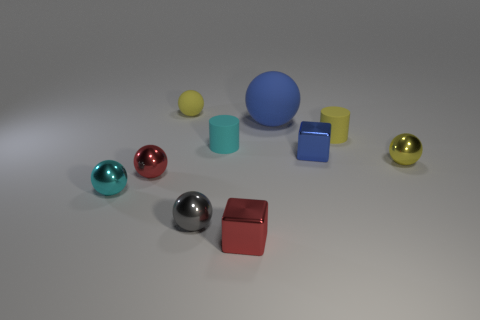Is there anything else that has the same material as the blue ball?
Provide a short and direct response. Yes. What shape is the small yellow object that is made of the same material as the tiny blue object?
Make the answer very short. Sphere. There is a cylinder to the right of the blue block; is its color the same as the small shiny sphere behind the tiny red metal ball?
Make the answer very short. Yes. Are there an equal number of small cyan cylinders behind the big sphere and small cyan shiny cylinders?
Offer a very short reply. Yes. There is a large blue rubber object; what number of cylinders are on the right side of it?
Keep it short and to the point. 1. How big is the blue ball?
Your response must be concise. Large. What is the color of the other small sphere that is made of the same material as the blue ball?
Keep it short and to the point. Yellow. How many cyan objects have the same size as the cyan metallic sphere?
Provide a short and direct response. 1. Do the small yellow sphere on the left side of the blue metal object and the tiny gray ball have the same material?
Keep it short and to the point. No. Are there fewer small yellow cylinders left of the tiny gray metal sphere than red balls?
Provide a short and direct response. Yes. 